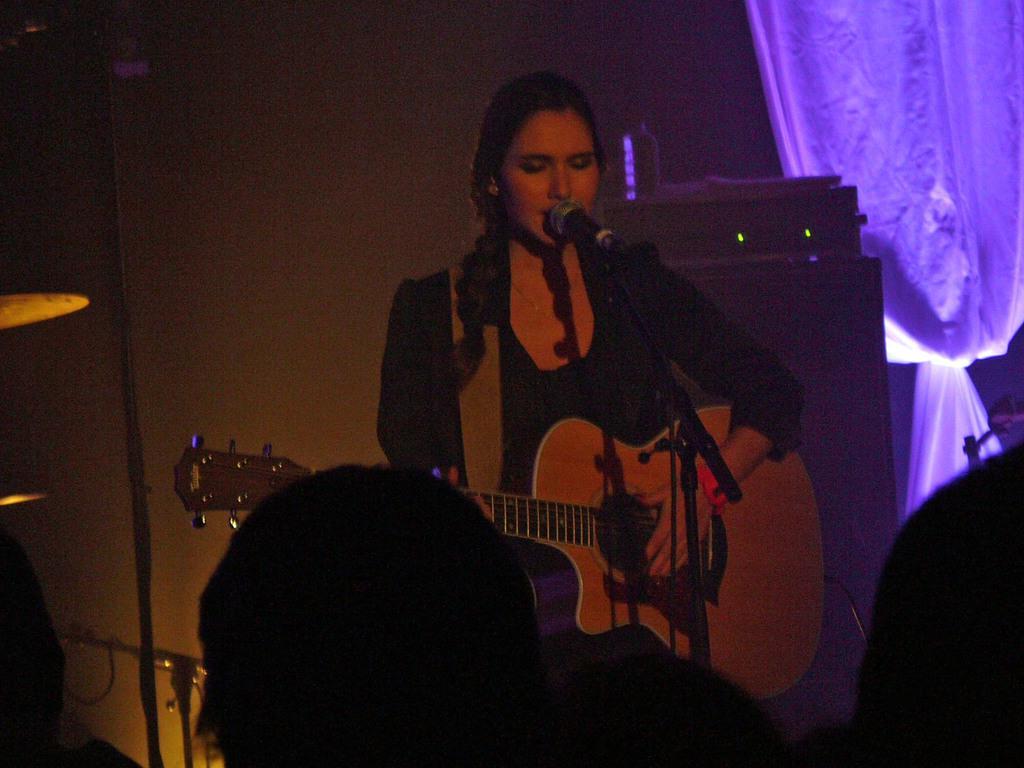Please provide a concise description of this image. This picture shows a woman standing and playing guitar and singing with the help of a microphone and we see curtains to the wall and we see few audience watching 